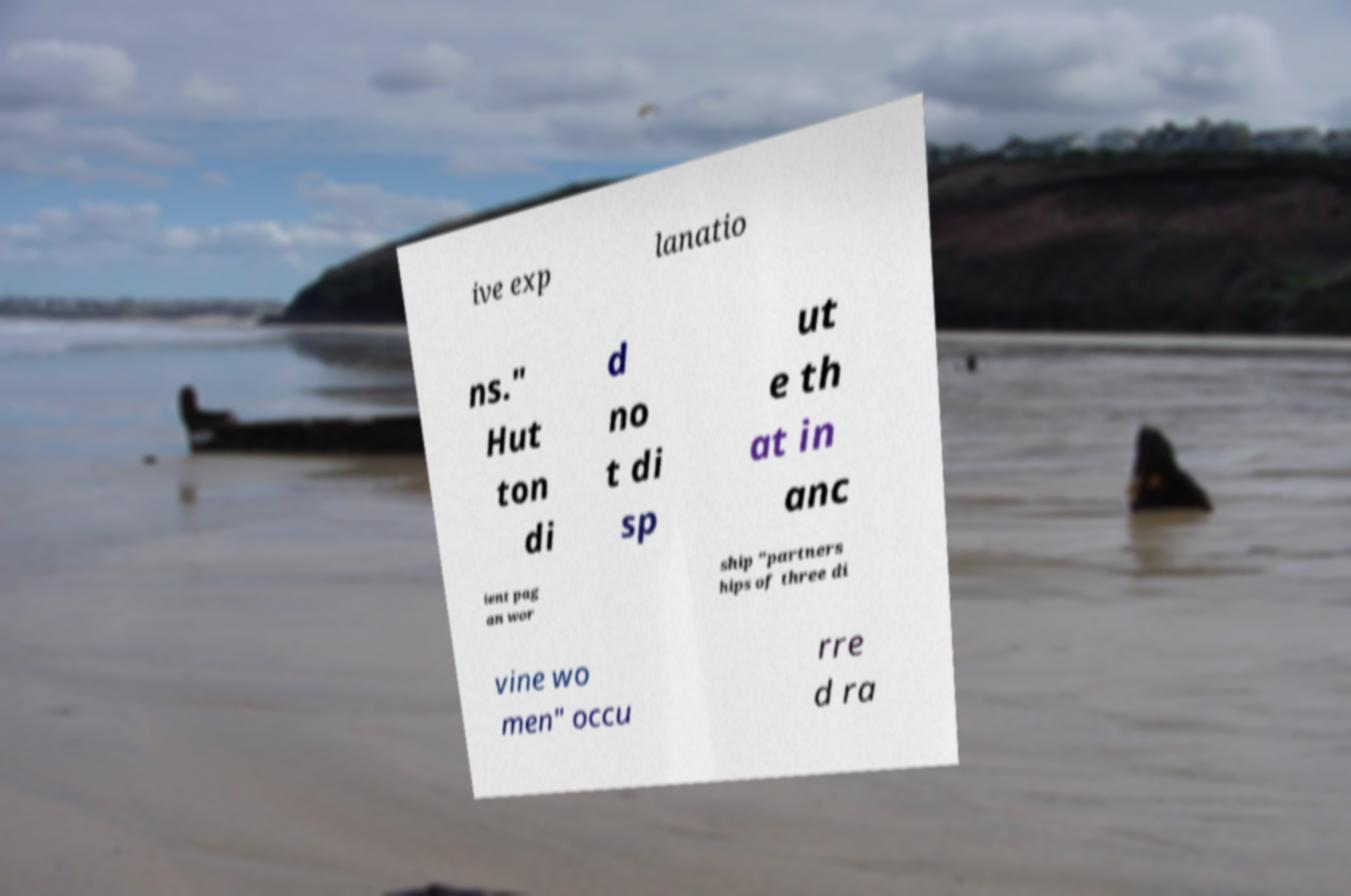Can you accurately transcribe the text from the provided image for me? ive exp lanatio ns." Hut ton di d no t di sp ut e th at in anc ient pag an wor ship "partners hips of three di vine wo men" occu rre d ra 